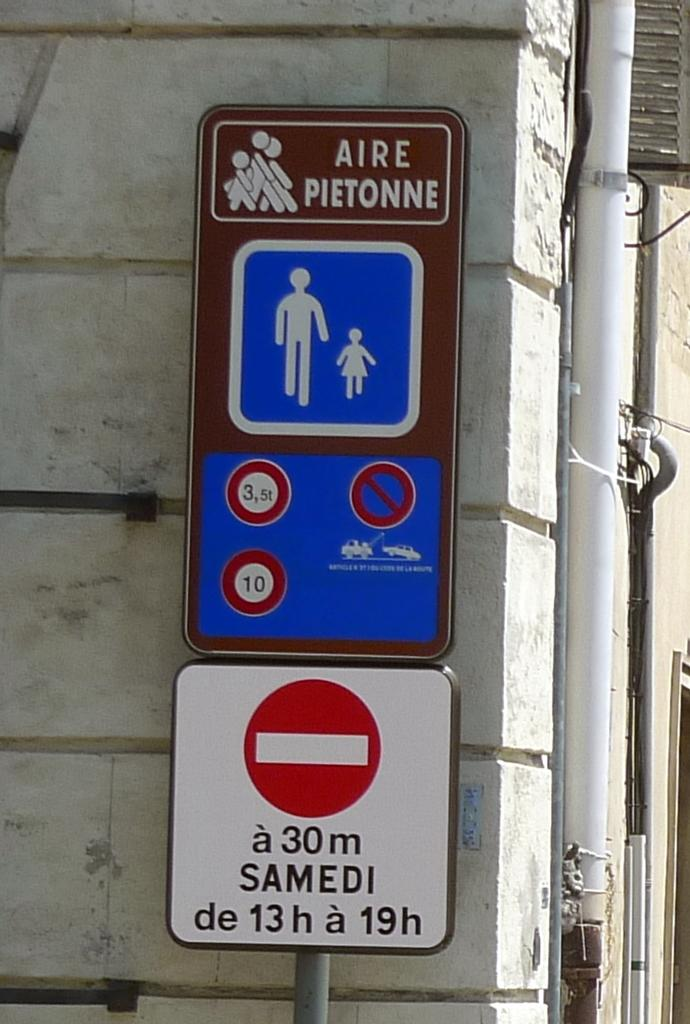Provide a one-sentence caption for the provided image. Signs are sitting next to a building with stating Aire Pietonne. 